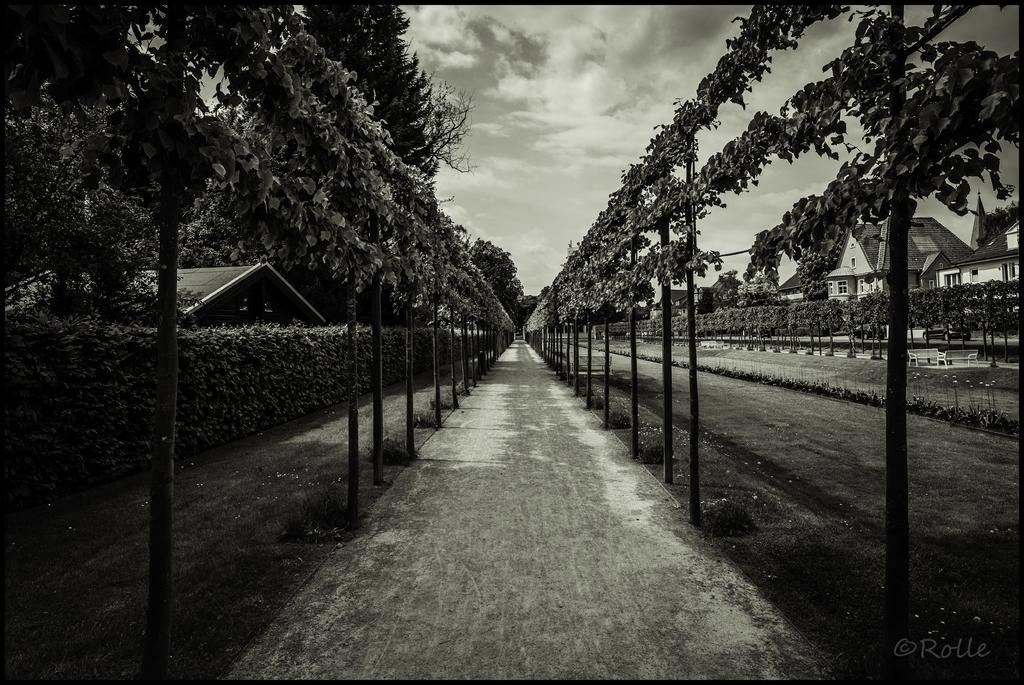What type of structures can be seen in the image? There are buildings in the image. What natural elements are present in the image? There are trees and grass in the image. What celestial bodies are visible in the image? Planets are visible in the image. What type of surface can be seen in the image? There is a path in the image. What is the condition of the sky in the image? The sky is cloudy in the image. What type of operation is being performed by the crow in the image? There is no crow present in the image, so no operation can be observed. What subject is being taught in the image? There is no teaching activity depicted in the image. 